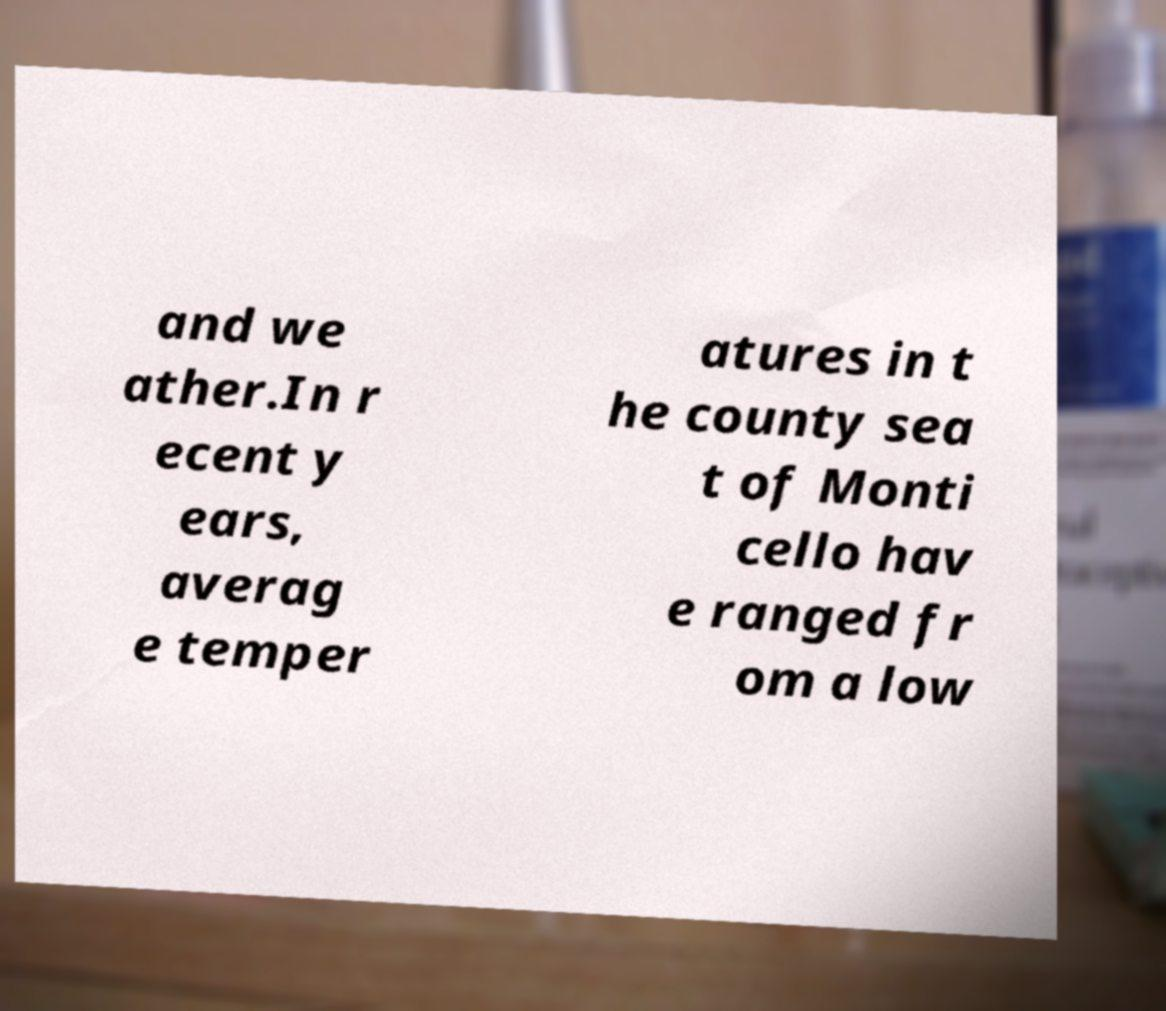Could you extract and type out the text from this image? and we ather.In r ecent y ears, averag e temper atures in t he county sea t of Monti cello hav e ranged fr om a low 